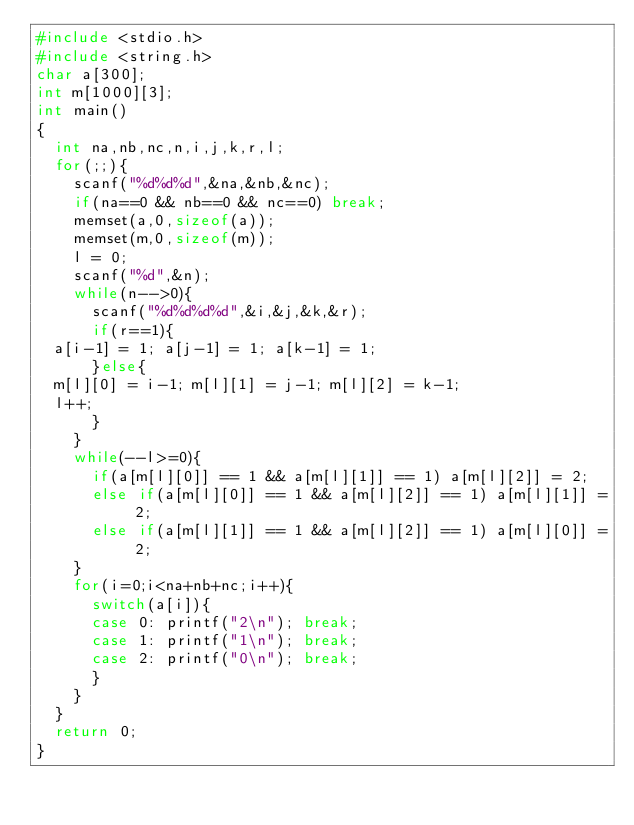Convert code to text. <code><loc_0><loc_0><loc_500><loc_500><_C_>#include <stdio.h>
#include <string.h>
char a[300];
int m[1000][3];
int main()
{
  int na,nb,nc,n,i,j,k,r,l;
  for(;;){
    scanf("%d%d%d",&na,&nb,&nc);
    if(na==0 && nb==0 && nc==0) break;
    memset(a,0,sizeof(a));
    memset(m,0,sizeof(m));
    l = 0;
    scanf("%d",&n);
    while(n-->0){
      scanf("%d%d%d%d",&i,&j,&k,&r);
      if(r==1){
	a[i-1] = 1; a[j-1] = 1; a[k-1] = 1;
      }else{
	m[l][0] = i-1; m[l][1] = j-1; m[l][2] = k-1;
	l++;
      }
    }
    while(--l>=0){
      if(a[m[l][0]] == 1 && a[m[l][1]] == 1) a[m[l][2]] = 2;
      else if(a[m[l][0]] == 1 && a[m[l][2]] == 1) a[m[l][1]] = 2;
      else if(a[m[l][1]] == 1 && a[m[l][2]] == 1) a[m[l][0]] = 2;
    }
    for(i=0;i<na+nb+nc;i++){
      switch(a[i]){
      case 0: printf("2\n"); break;
      case 1: printf("1\n"); break;
      case 2: printf("0\n"); break;
      }
    }
  }
  return 0;
}</code> 